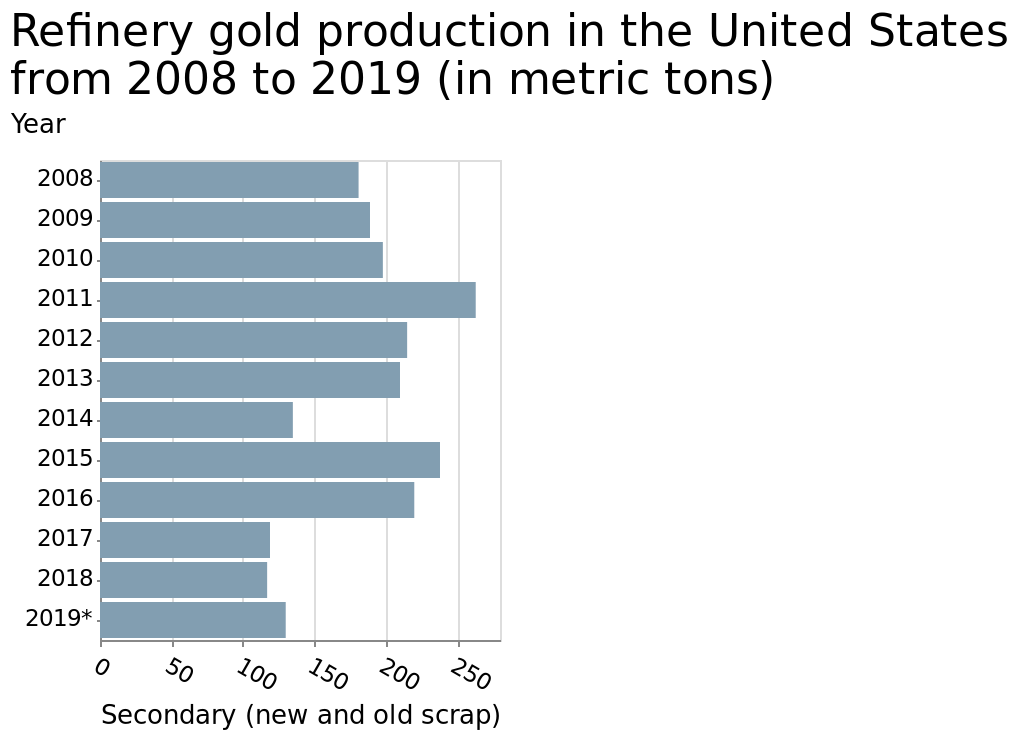<image>
What does the x-axis represent on the bar plot? The x-axis on the bar plot represents Secondary (new and old scrap). What was the highest production year for refinery gold in the United States?  The highest production year for refinery gold in the United States was 2011. please describe the details of the chart Here a is a bar plot labeled Refinery gold production in the United States from 2008 to 2019 (in metric tons). The x-axis plots Secondary (new and old scrap) while the y-axis measures Year. How much refinery gold was produced in the United States in 2011?  In 2011, over 250 metric tons of refinery gold were produced in the United States. Does the x-axis on the bar plot represent Primary (new and old scrap)? No.The x-axis on the bar plot represents Secondary (new and old scrap). 